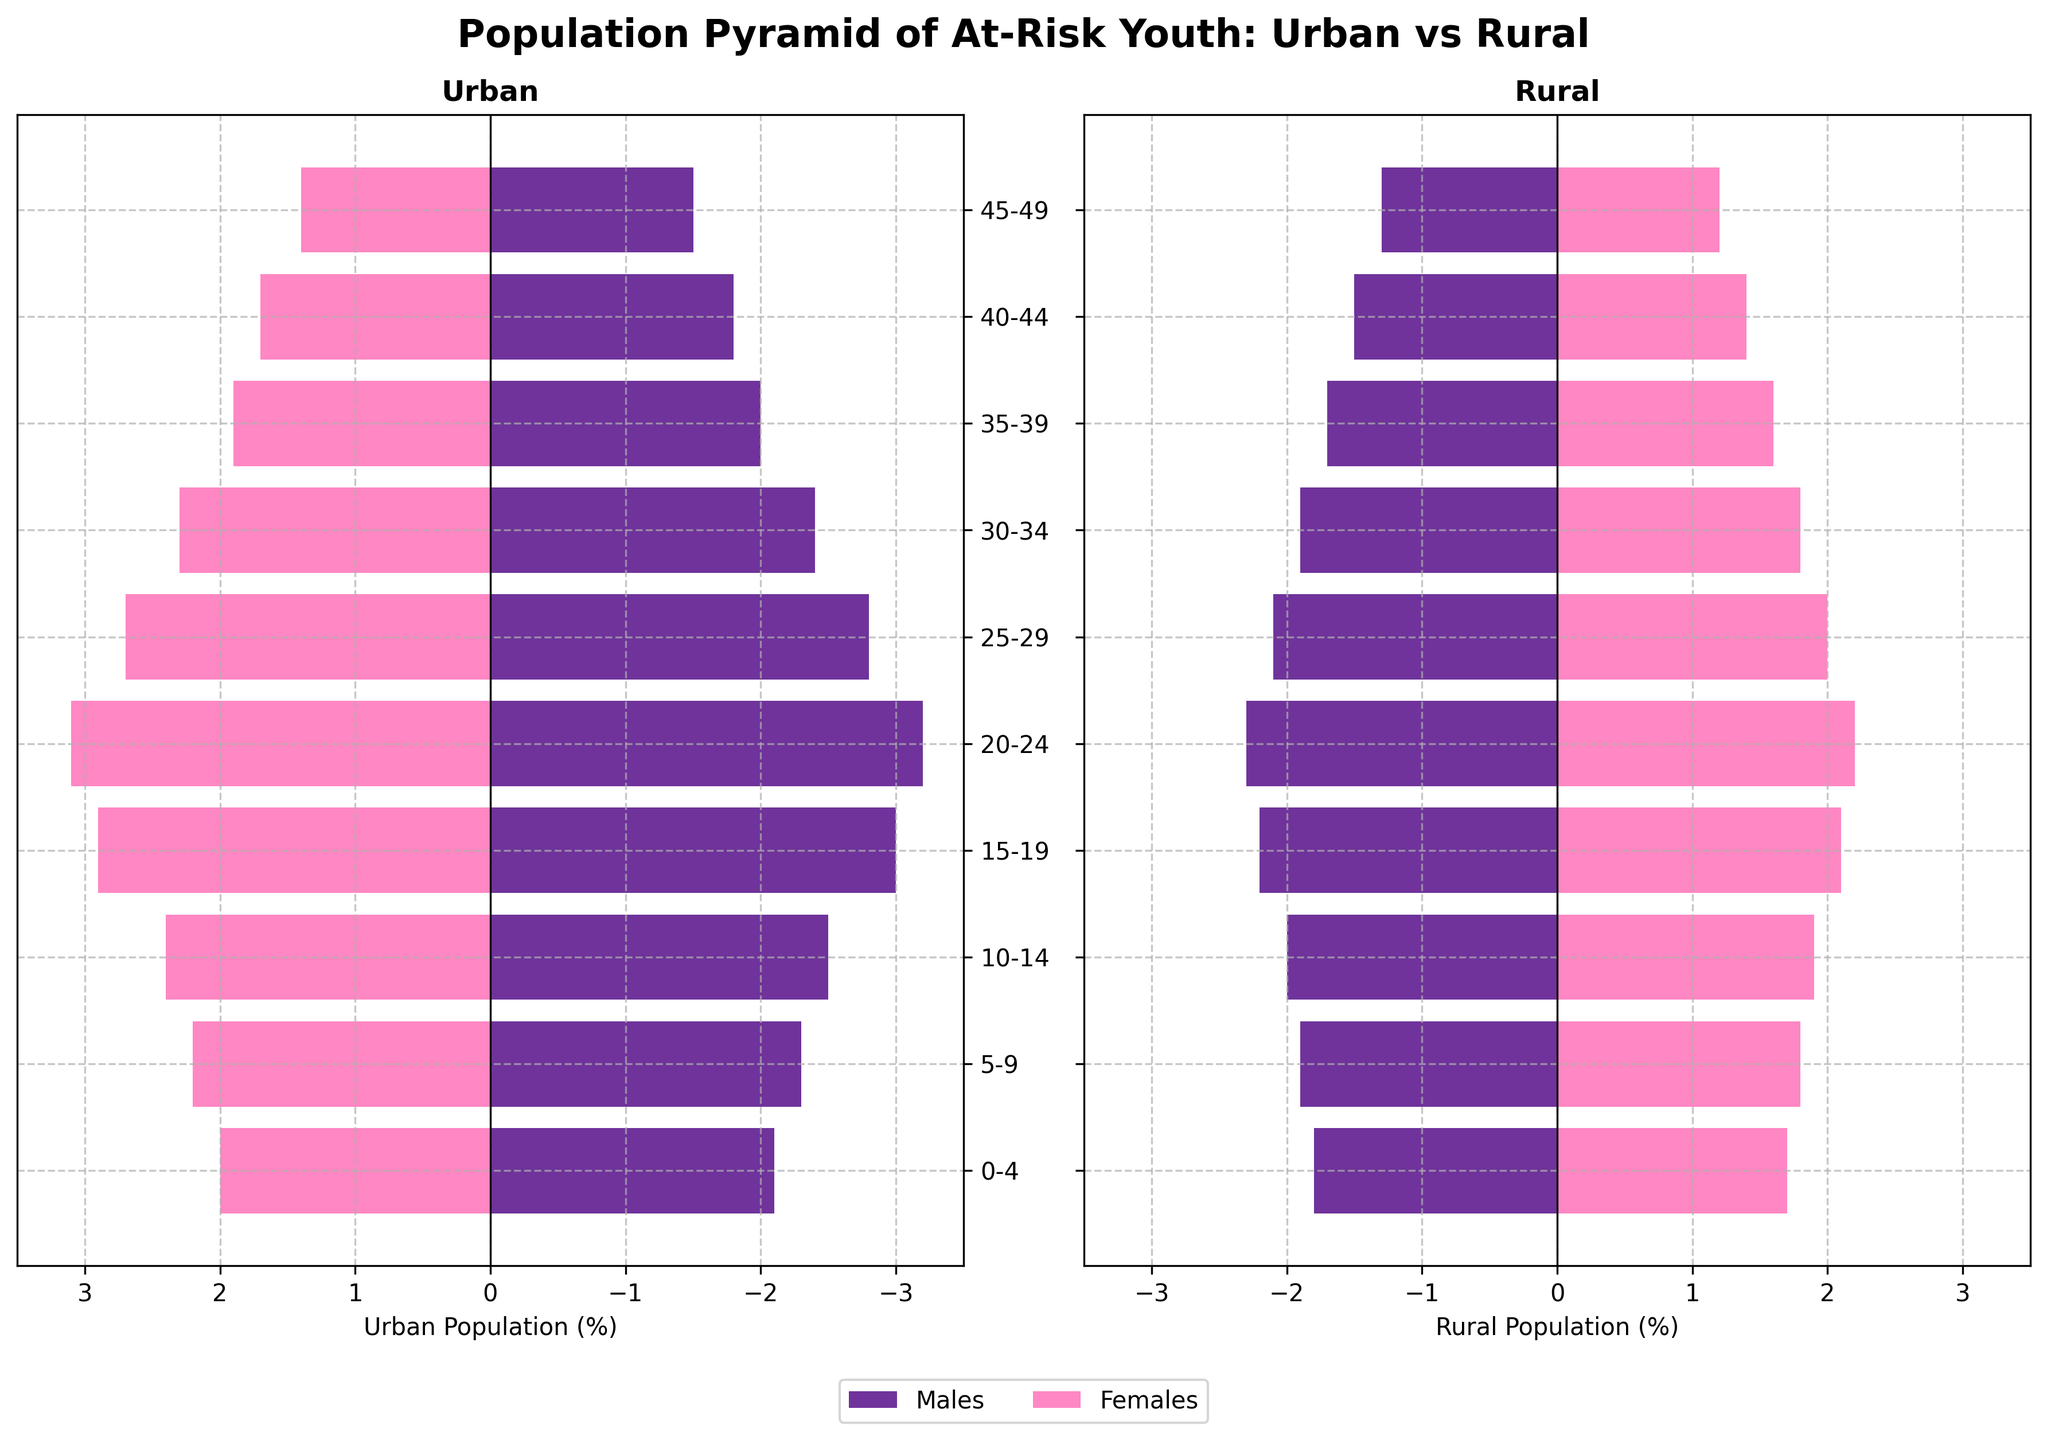What is the title of the figure? The title of the figure is written at the top of the plot. It reads 'Population Pyramid of At-Risk Youth: Urban vs Rural'.
Answer: 'Population Pyramid of At-Risk Youth: Urban vs Rural' What is the population percentage of urban males in the 20-24 age group? To find the population percentage of urban males in the 20-24 age group, look at the horizontal bar corresponding to that age range in the "Urban" section. The percentage extends to -3.2.
Answer: -3.2% Which age group has the highest percentage of at-risk urban females? Compare the lengths of the bars for urban females across all age groups. The 20-24 age group has the longest bar at 3.1.
Answer: 20-24 How much larger is the percentage of at-risk urban males in the 15-19 age group compared to rural males of the same age group? The population of at-risk urban males (15-19) is -3.0 and rural males (15-19) is -2.2. The difference is 3.0 - 2.2 = 0.8.
Answer: 0.8% What is the total percentage of at-risk rural females aged 0-4 and 10-14 combined? The percentage of at-risk rural females aged 0-4 is 1.7 and aged 10-14 is 1.9. Add these values to get 1.7 + 1.9 = 3.6.
Answer: 3.6% Which gender has a higher percentage of at-risk youth in the rural 5-9 age group, and by how much? Compare the horizontal bars for rural males and females in the 5-9 age group. Rural males have -1.9 and rural females have 1.8. The absolute value for males is larger by 0.1.
Answer: Males by 0.1% What is the trend in the number of at-risk urban males as the age group increases from 0-4 to 25-29? Observing the horizontal bars for urban males across the age groups 0-4 to 25-29, the percentages increase from -2.1 to -3.2 until 20-24, then it decreases to -2.8 in the 25-29 age group.
Answer: Increases then decreases In the age group of 30-34, which population group (urban males or rural females) has a lower at-risk youth percentage and by how much? Urban males in the 30-34 age group have -2.4 and rural females have 1.8. The absolute values are compared, resulting in 2.4 (urban males) - 1.8 (rural females) = 0.6.
Answer: Rural females by 0.6 What is the population percentage difference between urban and rural females aged 40-44? Compare the populations: urban females have 1.7 and rural females have 1.4 in the 40-44 age group. The difference is 1.7 - 1.4 = 0.3.
Answer: 0.3% Which population group has the least percentage of at-risk youth in the 45-49 age group? Observe the horizontal bars for the 45-49 age group: urban males (-1.5), urban females (1.4), rural males (-1.3), rural females (1.2). The smallest absolute value is for rural females at 1.2.
Answer: Rural females 